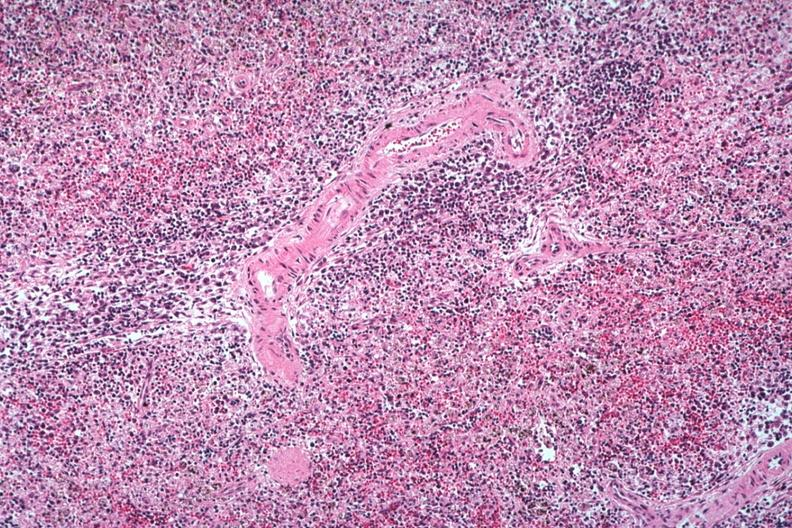what died of viral pneumonia likely to have been influenzae?
Answer the question using a single word or phrase. Well seen atypical cells surrounding splenic arteriole man probably 